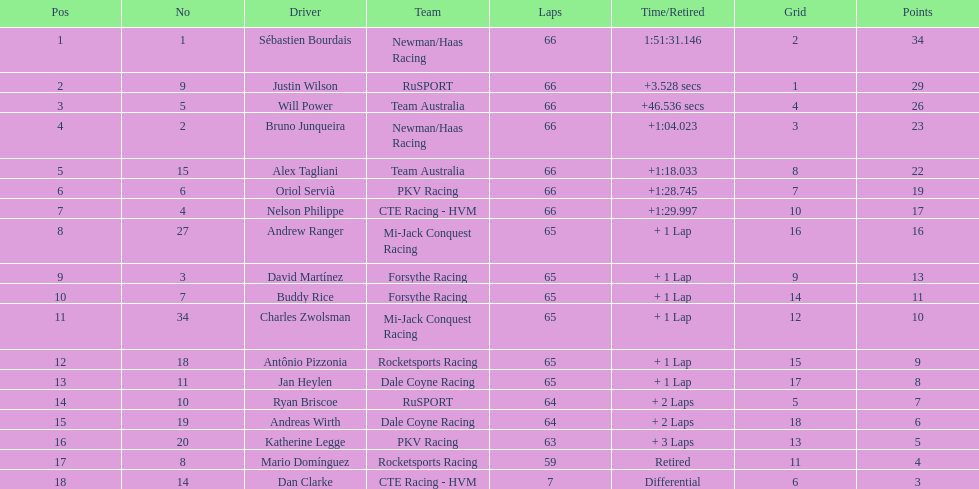In the 2006 gran premio telmex, who was the last to finish? Dan Clarke. 